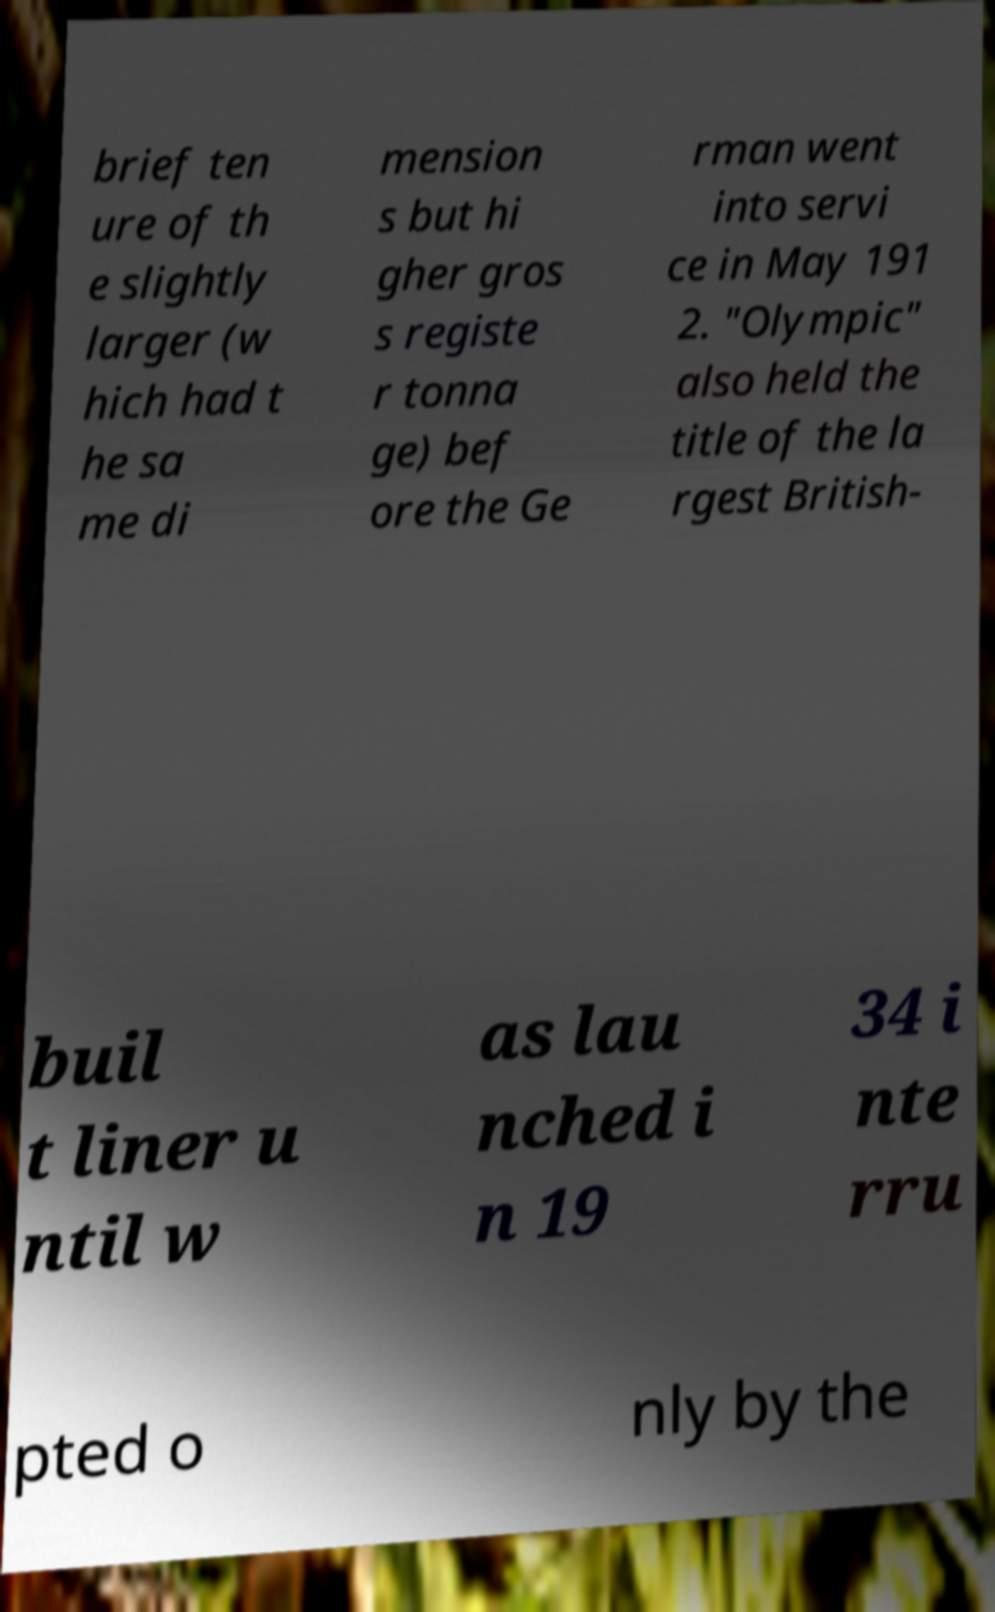I need the written content from this picture converted into text. Can you do that? brief ten ure of th e slightly larger (w hich had t he sa me di mension s but hi gher gros s registe r tonna ge) bef ore the Ge rman went into servi ce in May 191 2. "Olympic" also held the title of the la rgest British- buil t liner u ntil w as lau nched i n 19 34 i nte rru pted o nly by the 